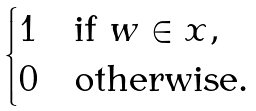Convert formula to latex. <formula><loc_0><loc_0><loc_500><loc_500>\begin{cases} 1 & \text {if $w\in x$} , \\ 0 & \text {otherwise} . \end{cases}</formula> 